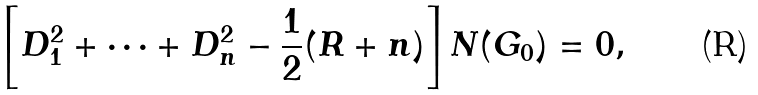Convert formula to latex. <formula><loc_0><loc_0><loc_500><loc_500>\left [ D _ { 1 } ^ { 2 } + \dots + D _ { n } ^ { 2 } - \frac { 1 } { 2 } ( R + n ) \right ] N ( G _ { 0 } ) = 0 ,</formula> 